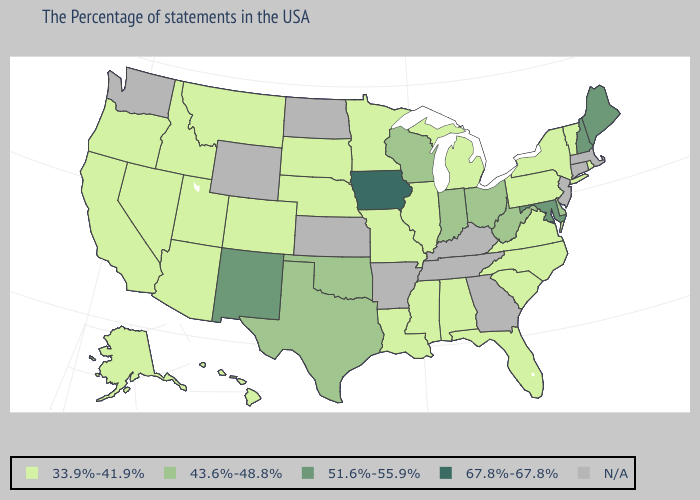Name the states that have a value in the range 33.9%-41.9%?
Concise answer only. Rhode Island, Vermont, New York, Pennsylvania, Virginia, North Carolina, South Carolina, Florida, Michigan, Alabama, Illinois, Mississippi, Louisiana, Missouri, Minnesota, Nebraska, South Dakota, Colorado, Utah, Montana, Arizona, Idaho, Nevada, California, Oregon, Alaska, Hawaii. Does the map have missing data?
Give a very brief answer. Yes. What is the highest value in states that border Kentucky?
Give a very brief answer. 43.6%-48.8%. What is the value of Wyoming?
Concise answer only. N/A. Name the states that have a value in the range 43.6%-48.8%?
Answer briefly. Delaware, West Virginia, Ohio, Indiana, Wisconsin, Oklahoma, Texas. Which states have the lowest value in the USA?
Keep it brief. Rhode Island, Vermont, New York, Pennsylvania, Virginia, North Carolina, South Carolina, Florida, Michigan, Alabama, Illinois, Mississippi, Louisiana, Missouri, Minnesota, Nebraska, South Dakota, Colorado, Utah, Montana, Arizona, Idaho, Nevada, California, Oregon, Alaska, Hawaii. Is the legend a continuous bar?
Answer briefly. No. What is the value of Illinois?
Keep it brief. 33.9%-41.9%. Is the legend a continuous bar?
Be succinct. No. What is the value of Idaho?
Be succinct. 33.9%-41.9%. What is the lowest value in the MidWest?
Be succinct. 33.9%-41.9%. Does Alabama have the lowest value in the USA?
Answer briefly. Yes. Name the states that have a value in the range N/A?
Give a very brief answer. Massachusetts, Connecticut, New Jersey, Georgia, Kentucky, Tennessee, Arkansas, Kansas, North Dakota, Wyoming, Washington. What is the highest value in the USA?
Keep it brief. 67.8%-67.8%. 